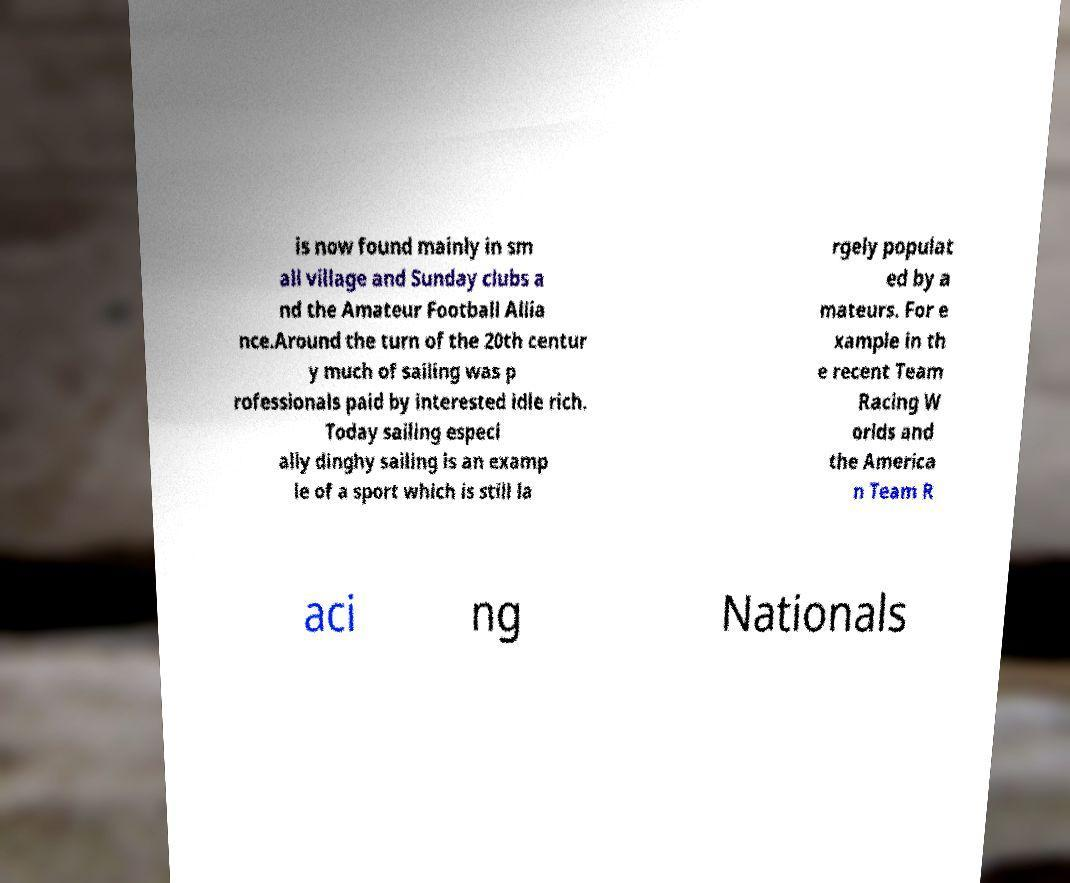Please identify and transcribe the text found in this image. is now found mainly in sm all village and Sunday clubs a nd the Amateur Football Allia nce.Around the turn of the 20th centur y much of sailing was p rofessionals paid by interested idle rich. Today sailing especi ally dinghy sailing is an examp le of a sport which is still la rgely populat ed by a mateurs. For e xample in th e recent Team Racing W orlds and the America n Team R aci ng Nationals 